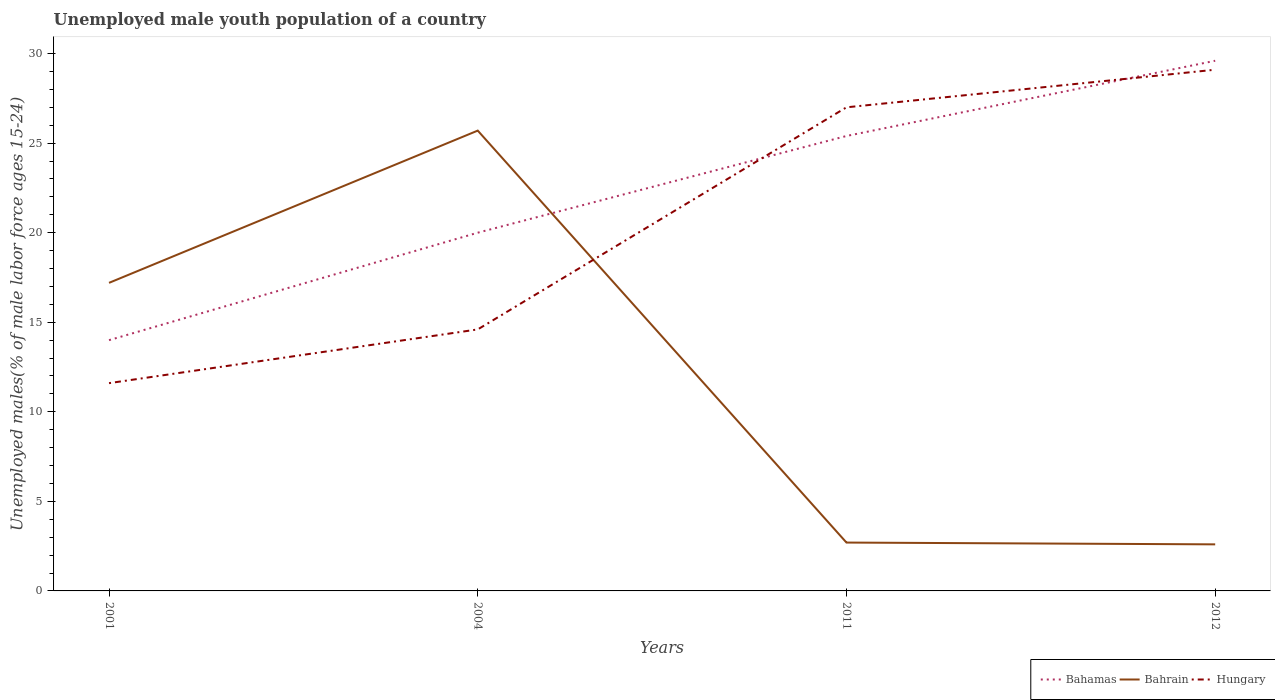How many different coloured lines are there?
Offer a terse response. 3. Does the line corresponding to Hungary intersect with the line corresponding to Bahamas?
Your response must be concise. Yes. Across all years, what is the maximum percentage of unemployed male youth population in Bahrain?
Your answer should be compact. 2.6. In which year was the percentage of unemployed male youth population in Hungary maximum?
Offer a very short reply. 2001. What is the total percentage of unemployed male youth population in Bahrain in the graph?
Your response must be concise. 0.1. What is the difference between the highest and the second highest percentage of unemployed male youth population in Hungary?
Make the answer very short. 17.5. Is the percentage of unemployed male youth population in Hungary strictly greater than the percentage of unemployed male youth population in Bahamas over the years?
Your answer should be very brief. No. How many lines are there?
Your answer should be very brief. 3. What is the difference between two consecutive major ticks on the Y-axis?
Provide a succinct answer. 5. Does the graph contain grids?
Give a very brief answer. No. Where does the legend appear in the graph?
Your response must be concise. Bottom right. How many legend labels are there?
Your answer should be very brief. 3. How are the legend labels stacked?
Offer a very short reply. Horizontal. What is the title of the graph?
Your answer should be very brief. Unemployed male youth population of a country. What is the label or title of the X-axis?
Give a very brief answer. Years. What is the label or title of the Y-axis?
Ensure brevity in your answer.  Unemployed males(% of male labor force ages 15-24). What is the Unemployed males(% of male labor force ages 15-24) in Bahamas in 2001?
Provide a succinct answer. 14. What is the Unemployed males(% of male labor force ages 15-24) in Bahrain in 2001?
Give a very brief answer. 17.2. What is the Unemployed males(% of male labor force ages 15-24) of Hungary in 2001?
Your answer should be compact. 11.6. What is the Unemployed males(% of male labor force ages 15-24) in Bahrain in 2004?
Make the answer very short. 25.7. What is the Unemployed males(% of male labor force ages 15-24) of Hungary in 2004?
Your answer should be very brief. 14.6. What is the Unemployed males(% of male labor force ages 15-24) of Bahamas in 2011?
Your answer should be very brief. 25.4. What is the Unemployed males(% of male labor force ages 15-24) in Bahrain in 2011?
Give a very brief answer. 2.7. What is the Unemployed males(% of male labor force ages 15-24) in Bahamas in 2012?
Make the answer very short. 29.6. What is the Unemployed males(% of male labor force ages 15-24) of Bahrain in 2012?
Offer a terse response. 2.6. What is the Unemployed males(% of male labor force ages 15-24) in Hungary in 2012?
Offer a very short reply. 29.1. Across all years, what is the maximum Unemployed males(% of male labor force ages 15-24) of Bahamas?
Provide a succinct answer. 29.6. Across all years, what is the maximum Unemployed males(% of male labor force ages 15-24) in Bahrain?
Give a very brief answer. 25.7. Across all years, what is the maximum Unemployed males(% of male labor force ages 15-24) of Hungary?
Give a very brief answer. 29.1. Across all years, what is the minimum Unemployed males(% of male labor force ages 15-24) of Bahrain?
Provide a short and direct response. 2.6. Across all years, what is the minimum Unemployed males(% of male labor force ages 15-24) in Hungary?
Your response must be concise. 11.6. What is the total Unemployed males(% of male labor force ages 15-24) of Bahamas in the graph?
Offer a terse response. 89. What is the total Unemployed males(% of male labor force ages 15-24) in Bahrain in the graph?
Your answer should be compact. 48.2. What is the total Unemployed males(% of male labor force ages 15-24) of Hungary in the graph?
Give a very brief answer. 82.3. What is the difference between the Unemployed males(% of male labor force ages 15-24) in Bahamas in 2001 and that in 2004?
Your answer should be very brief. -6. What is the difference between the Unemployed males(% of male labor force ages 15-24) in Bahrain in 2001 and that in 2004?
Offer a very short reply. -8.5. What is the difference between the Unemployed males(% of male labor force ages 15-24) of Hungary in 2001 and that in 2004?
Your answer should be compact. -3. What is the difference between the Unemployed males(% of male labor force ages 15-24) of Bahrain in 2001 and that in 2011?
Ensure brevity in your answer.  14.5. What is the difference between the Unemployed males(% of male labor force ages 15-24) in Hungary in 2001 and that in 2011?
Your answer should be very brief. -15.4. What is the difference between the Unemployed males(% of male labor force ages 15-24) of Bahamas in 2001 and that in 2012?
Offer a very short reply. -15.6. What is the difference between the Unemployed males(% of male labor force ages 15-24) in Hungary in 2001 and that in 2012?
Make the answer very short. -17.5. What is the difference between the Unemployed males(% of male labor force ages 15-24) in Bahamas in 2004 and that in 2011?
Give a very brief answer. -5.4. What is the difference between the Unemployed males(% of male labor force ages 15-24) in Hungary in 2004 and that in 2011?
Ensure brevity in your answer.  -12.4. What is the difference between the Unemployed males(% of male labor force ages 15-24) in Bahamas in 2004 and that in 2012?
Your response must be concise. -9.6. What is the difference between the Unemployed males(% of male labor force ages 15-24) in Bahrain in 2004 and that in 2012?
Provide a succinct answer. 23.1. What is the difference between the Unemployed males(% of male labor force ages 15-24) in Hungary in 2004 and that in 2012?
Your answer should be very brief. -14.5. What is the difference between the Unemployed males(% of male labor force ages 15-24) in Bahamas in 2011 and that in 2012?
Your answer should be compact. -4.2. What is the difference between the Unemployed males(% of male labor force ages 15-24) in Hungary in 2011 and that in 2012?
Provide a succinct answer. -2.1. What is the difference between the Unemployed males(% of male labor force ages 15-24) of Bahamas in 2001 and the Unemployed males(% of male labor force ages 15-24) of Hungary in 2004?
Provide a short and direct response. -0.6. What is the difference between the Unemployed males(% of male labor force ages 15-24) in Bahamas in 2001 and the Unemployed males(% of male labor force ages 15-24) in Bahrain in 2012?
Provide a short and direct response. 11.4. What is the difference between the Unemployed males(% of male labor force ages 15-24) of Bahamas in 2001 and the Unemployed males(% of male labor force ages 15-24) of Hungary in 2012?
Your answer should be very brief. -15.1. What is the difference between the Unemployed males(% of male labor force ages 15-24) in Bahamas in 2004 and the Unemployed males(% of male labor force ages 15-24) in Bahrain in 2011?
Give a very brief answer. 17.3. What is the difference between the Unemployed males(% of male labor force ages 15-24) of Bahrain in 2004 and the Unemployed males(% of male labor force ages 15-24) of Hungary in 2011?
Your answer should be very brief. -1.3. What is the difference between the Unemployed males(% of male labor force ages 15-24) in Bahamas in 2011 and the Unemployed males(% of male labor force ages 15-24) in Bahrain in 2012?
Provide a short and direct response. 22.8. What is the difference between the Unemployed males(% of male labor force ages 15-24) of Bahrain in 2011 and the Unemployed males(% of male labor force ages 15-24) of Hungary in 2012?
Ensure brevity in your answer.  -26.4. What is the average Unemployed males(% of male labor force ages 15-24) in Bahamas per year?
Make the answer very short. 22.25. What is the average Unemployed males(% of male labor force ages 15-24) of Bahrain per year?
Ensure brevity in your answer.  12.05. What is the average Unemployed males(% of male labor force ages 15-24) in Hungary per year?
Ensure brevity in your answer.  20.57. In the year 2001, what is the difference between the Unemployed males(% of male labor force ages 15-24) of Bahamas and Unemployed males(% of male labor force ages 15-24) of Bahrain?
Offer a very short reply. -3.2. In the year 2001, what is the difference between the Unemployed males(% of male labor force ages 15-24) of Bahrain and Unemployed males(% of male labor force ages 15-24) of Hungary?
Offer a terse response. 5.6. In the year 2004, what is the difference between the Unemployed males(% of male labor force ages 15-24) of Bahamas and Unemployed males(% of male labor force ages 15-24) of Bahrain?
Offer a very short reply. -5.7. In the year 2004, what is the difference between the Unemployed males(% of male labor force ages 15-24) in Bahamas and Unemployed males(% of male labor force ages 15-24) in Hungary?
Your answer should be compact. 5.4. In the year 2011, what is the difference between the Unemployed males(% of male labor force ages 15-24) of Bahamas and Unemployed males(% of male labor force ages 15-24) of Bahrain?
Offer a very short reply. 22.7. In the year 2011, what is the difference between the Unemployed males(% of male labor force ages 15-24) of Bahamas and Unemployed males(% of male labor force ages 15-24) of Hungary?
Your response must be concise. -1.6. In the year 2011, what is the difference between the Unemployed males(% of male labor force ages 15-24) of Bahrain and Unemployed males(% of male labor force ages 15-24) of Hungary?
Make the answer very short. -24.3. In the year 2012, what is the difference between the Unemployed males(% of male labor force ages 15-24) in Bahamas and Unemployed males(% of male labor force ages 15-24) in Bahrain?
Offer a terse response. 27. In the year 2012, what is the difference between the Unemployed males(% of male labor force ages 15-24) in Bahamas and Unemployed males(% of male labor force ages 15-24) in Hungary?
Ensure brevity in your answer.  0.5. In the year 2012, what is the difference between the Unemployed males(% of male labor force ages 15-24) in Bahrain and Unemployed males(% of male labor force ages 15-24) in Hungary?
Make the answer very short. -26.5. What is the ratio of the Unemployed males(% of male labor force ages 15-24) of Bahamas in 2001 to that in 2004?
Provide a succinct answer. 0.7. What is the ratio of the Unemployed males(% of male labor force ages 15-24) of Bahrain in 2001 to that in 2004?
Your answer should be compact. 0.67. What is the ratio of the Unemployed males(% of male labor force ages 15-24) in Hungary in 2001 to that in 2004?
Ensure brevity in your answer.  0.79. What is the ratio of the Unemployed males(% of male labor force ages 15-24) of Bahamas in 2001 to that in 2011?
Provide a short and direct response. 0.55. What is the ratio of the Unemployed males(% of male labor force ages 15-24) in Bahrain in 2001 to that in 2011?
Your answer should be very brief. 6.37. What is the ratio of the Unemployed males(% of male labor force ages 15-24) in Hungary in 2001 to that in 2011?
Provide a succinct answer. 0.43. What is the ratio of the Unemployed males(% of male labor force ages 15-24) in Bahamas in 2001 to that in 2012?
Give a very brief answer. 0.47. What is the ratio of the Unemployed males(% of male labor force ages 15-24) of Bahrain in 2001 to that in 2012?
Ensure brevity in your answer.  6.62. What is the ratio of the Unemployed males(% of male labor force ages 15-24) in Hungary in 2001 to that in 2012?
Offer a very short reply. 0.4. What is the ratio of the Unemployed males(% of male labor force ages 15-24) in Bahamas in 2004 to that in 2011?
Provide a short and direct response. 0.79. What is the ratio of the Unemployed males(% of male labor force ages 15-24) of Bahrain in 2004 to that in 2011?
Make the answer very short. 9.52. What is the ratio of the Unemployed males(% of male labor force ages 15-24) in Hungary in 2004 to that in 2011?
Keep it short and to the point. 0.54. What is the ratio of the Unemployed males(% of male labor force ages 15-24) of Bahamas in 2004 to that in 2012?
Provide a short and direct response. 0.68. What is the ratio of the Unemployed males(% of male labor force ages 15-24) in Bahrain in 2004 to that in 2012?
Your answer should be very brief. 9.88. What is the ratio of the Unemployed males(% of male labor force ages 15-24) in Hungary in 2004 to that in 2012?
Your answer should be very brief. 0.5. What is the ratio of the Unemployed males(% of male labor force ages 15-24) in Bahamas in 2011 to that in 2012?
Keep it short and to the point. 0.86. What is the ratio of the Unemployed males(% of male labor force ages 15-24) in Bahrain in 2011 to that in 2012?
Offer a terse response. 1.04. What is the ratio of the Unemployed males(% of male labor force ages 15-24) of Hungary in 2011 to that in 2012?
Your response must be concise. 0.93. What is the difference between the highest and the second highest Unemployed males(% of male labor force ages 15-24) in Bahrain?
Your response must be concise. 8.5. What is the difference between the highest and the lowest Unemployed males(% of male labor force ages 15-24) in Bahamas?
Your response must be concise. 15.6. What is the difference between the highest and the lowest Unemployed males(% of male labor force ages 15-24) of Bahrain?
Ensure brevity in your answer.  23.1. What is the difference between the highest and the lowest Unemployed males(% of male labor force ages 15-24) in Hungary?
Your response must be concise. 17.5. 